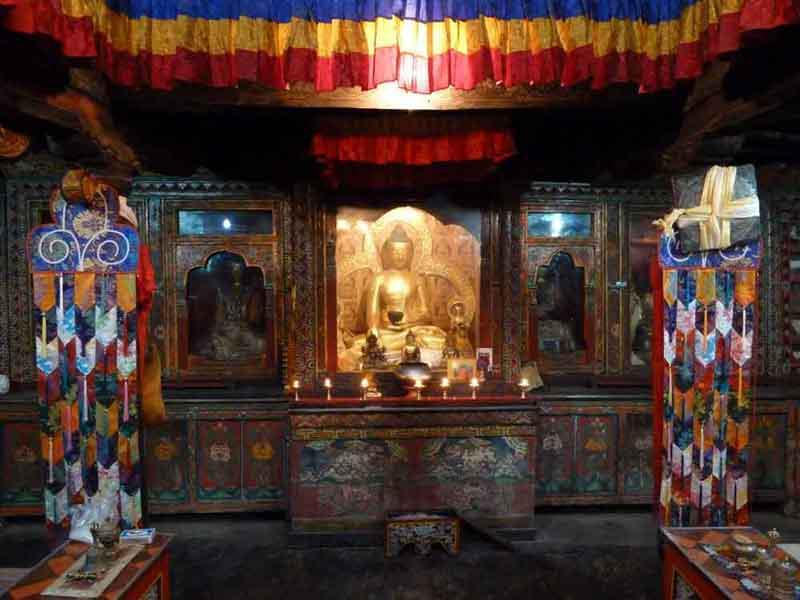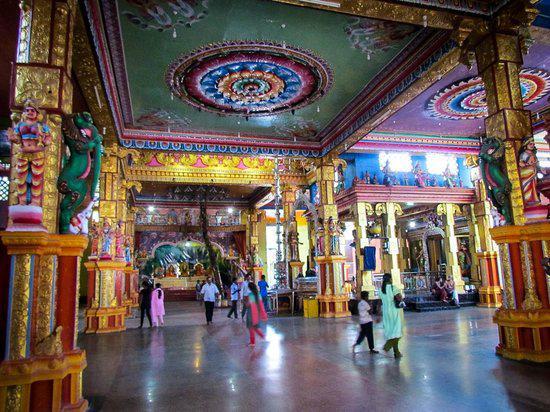The first image is the image on the left, the second image is the image on the right. Considering the images on both sides, is "The left image features three gold figures in lotus positions side-by-side in a row, with the figures on the ends wearing crowns." valid? Answer yes or no. No. 